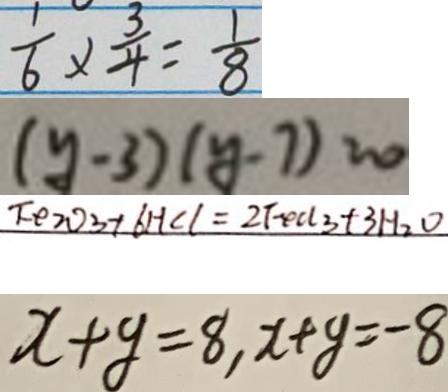Convert formula to latex. <formula><loc_0><loc_0><loc_500><loc_500>\frac { 1 } { 6 } \times \frac { 3 } { 4 } = \frac { 1 } { 8 } 
 ( y - 3 ) ( y - 7 ) = 0 
 F e _ { 2 } O _ { 3 } + 6 H C l = 2 F e C l _ { 3 } + 3 H _ { 2 } O 
 x + y = 8 , x + y = - 8</formula> 